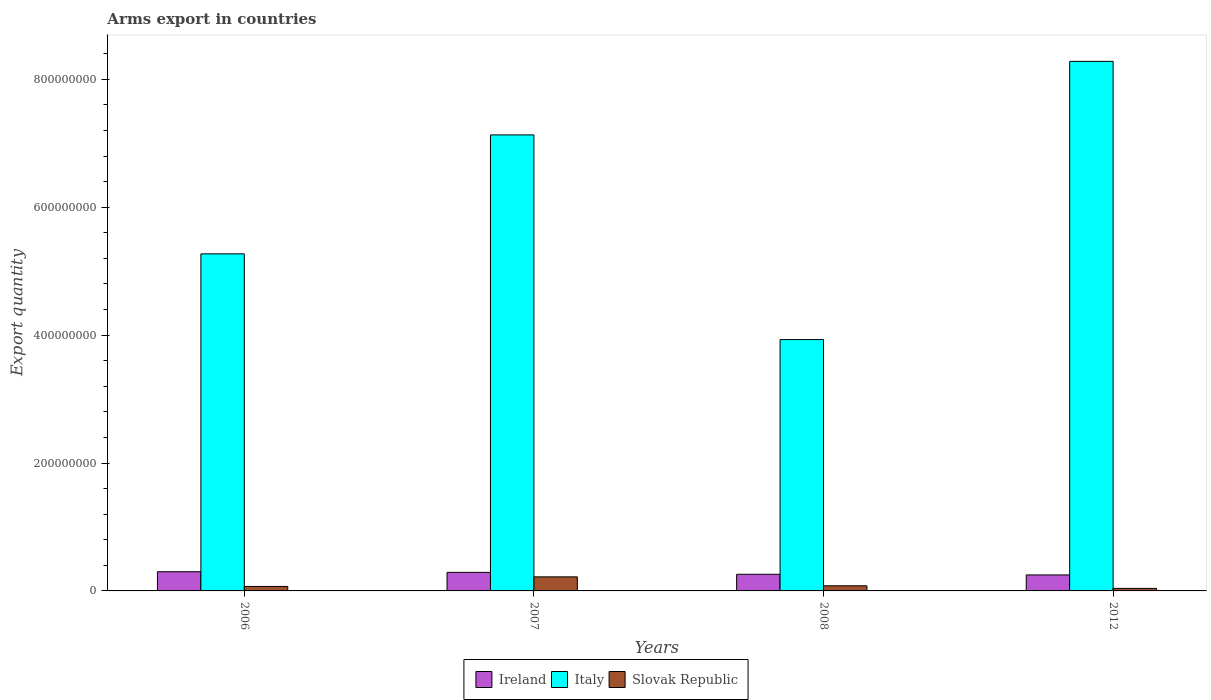How many groups of bars are there?
Ensure brevity in your answer.  4. What is the label of the 4th group of bars from the left?
Make the answer very short. 2012. In how many cases, is the number of bars for a given year not equal to the number of legend labels?
Your response must be concise. 0. What is the total arms export in Italy in 2006?
Give a very brief answer. 5.27e+08. Across all years, what is the maximum total arms export in Italy?
Provide a short and direct response. 8.28e+08. Across all years, what is the minimum total arms export in Slovak Republic?
Offer a very short reply. 4.00e+06. In which year was the total arms export in Ireland maximum?
Give a very brief answer. 2006. What is the total total arms export in Slovak Republic in the graph?
Keep it short and to the point. 4.10e+07. What is the difference between the total arms export in Slovak Republic in 2006 and that in 2007?
Give a very brief answer. -1.50e+07. What is the difference between the total arms export in Ireland in 2008 and the total arms export in Italy in 2006?
Ensure brevity in your answer.  -5.01e+08. What is the average total arms export in Ireland per year?
Ensure brevity in your answer.  2.75e+07. In the year 2007, what is the difference between the total arms export in Ireland and total arms export in Slovak Republic?
Provide a succinct answer. 7.00e+06. What is the ratio of the total arms export in Italy in 2006 to that in 2012?
Offer a very short reply. 0.64. Is the total arms export in Italy in 2006 less than that in 2012?
Your answer should be very brief. Yes. Is the difference between the total arms export in Ireland in 2008 and 2012 greater than the difference between the total arms export in Slovak Republic in 2008 and 2012?
Provide a short and direct response. No. What is the difference between the highest and the second highest total arms export in Slovak Republic?
Offer a terse response. 1.40e+07. What is the difference between the highest and the lowest total arms export in Italy?
Offer a terse response. 4.35e+08. What does the 1st bar from the left in 2006 represents?
Provide a short and direct response. Ireland. What does the 1st bar from the right in 2006 represents?
Provide a short and direct response. Slovak Republic. How many bars are there?
Provide a short and direct response. 12. Are all the bars in the graph horizontal?
Provide a short and direct response. No. How many years are there in the graph?
Make the answer very short. 4. What is the difference between two consecutive major ticks on the Y-axis?
Provide a short and direct response. 2.00e+08. Does the graph contain any zero values?
Give a very brief answer. No. Does the graph contain grids?
Your answer should be compact. No. How many legend labels are there?
Your response must be concise. 3. What is the title of the graph?
Give a very brief answer. Arms export in countries. What is the label or title of the Y-axis?
Your response must be concise. Export quantity. What is the Export quantity in Ireland in 2006?
Offer a terse response. 3.00e+07. What is the Export quantity in Italy in 2006?
Give a very brief answer. 5.27e+08. What is the Export quantity in Slovak Republic in 2006?
Your response must be concise. 7.00e+06. What is the Export quantity of Ireland in 2007?
Your response must be concise. 2.90e+07. What is the Export quantity of Italy in 2007?
Keep it short and to the point. 7.13e+08. What is the Export quantity in Slovak Republic in 2007?
Keep it short and to the point. 2.20e+07. What is the Export quantity of Ireland in 2008?
Your response must be concise. 2.60e+07. What is the Export quantity in Italy in 2008?
Make the answer very short. 3.93e+08. What is the Export quantity of Slovak Republic in 2008?
Give a very brief answer. 8.00e+06. What is the Export quantity in Ireland in 2012?
Offer a very short reply. 2.50e+07. What is the Export quantity of Italy in 2012?
Provide a short and direct response. 8.28e+08. Across all years, what is the maximum Export quantity in Ireland?
Offer a very short reply. 3.00e+07. Across all years, what is the maximum Export quantity of Italy?
Your response must be concise. 8.28e+08. Across all years, what is the maximum Export quantity of Slovak Republic?
Your answer should be very brief. 2.20e+07. Across all years, what is the minimum Export quantity of Ireland?
Give a very brief answer. 2.50e+07. Across all years, what is the minimum Export quantity of Italy?
Provide a succinct answer. 3.93e+08. Across all years, what is the minimum Export quantity in Slovak Republic?
Make the answer very short. 4.00e+06. What is the total Export quantity in Ireland in the graph?
Give a very brief answer. 1.10e+08. What is the total Export quantity in Italy in the graph?
Offer a very short reply. 2.46e+09. What is the total Export quantity in Slovak Republic in the graph?
Make the answer very short. 4.10e+07. What is the difference between the Export quantity of Italy in 2006 and that in 2007?
Your response must be concise. -1.86e+08. What is the difference between the Export quantity in Slovak Republic in 2006 and that in 2007?
Offer a terse response. -1.50e+07. What is the difference between the Export quantity of Italy in 2006 and that in 2008?
Offer a terse response. 1.34e+08. What is the difference between the Export quantity of Ireland in 2006 and that in 2012?
Keep it short and to the point. 5.00e+06. What is the difference between the Export quantity in Italy in 2006 and that in 2012?
Your response must be concise. -3.01e+08. What is the difference between the Export quantity in Ireland in 2007 and that in 2008?
Make the answer very short. 3.00e+06. What is the difference between the Export quantity in Italy in 2007 and that in 2008?
Your answer should be very brief. 3.20e+08. What is the difference between the Export quantity in Slovak Republic in 2007 and that in 2008?
Offer a terse response. 1.40e+07. What is the difference between the Export quantity in Italy in 2007 and that in 2012?
Your response must be concise. -1.15e+08. What is the difference between the Export quantity of Slovak Republic in 2007 and that in 2012?
Your answer should be very brief. 1.80e+07. What is the difference between the Export quantity of Italy in 2008 and that in 2012?
Make the answer very short. -4.35e+08. What is the difference between the Export quantity of Ireland in 2006 and the Export quantity of Italy in 2007?
Offer a very short reply. -6.83e+08. What is the difference between the Export quantity of Ireland in 2006 and the Export quantity of Slovak Republic in 2007?
Give a very brief answer. 8.00e+06. What is the difference between the Export quantity of Italy in 2006 and the Export quantity of Slovak Republic in 2007?
Your answer should be compact. 5.05e+08. What is the difference between the Export quantity in Ireland in 2006 and the Export quantity in Italy in 2008?
Your answer should be very brief. -3.63e+08. What is the difference between the Export quantity of Ireland in 2006 and the Export quantity of Slovak Republic in 2008?
Keep it short and to the point. 2.20e+07. What is the difference between the Export quantity of Italy in 2006 and the Export quantity of Slovak Republic in 2008?
Your answer should be very brief. 5.19e+08. What is the difference between the Export quantity in Ireland in 2006 and the Export quantity in Italy in 2012?
Make the answer very short. -7.98e+08. What is the difference between the Export quantity of Ireland in 2006 and the Export quantity of Slovak Republic in 2012?
Offer a very short reply. 2.60e+07. What is the difference between the Export quantity of Italy in 2006 and the Export quantity of Slovak Republic in 2012?
Offer a very short reply. 5.23e+08. What is the difference between the Export quantity in Ireland in 2007 and the Export quantity in Italy in 2008?
Ensure brevity in your answer.  -3.64e+08. What is the difference between the Export quantity in Ireland in 2007 and the Export quantity in Slovak Republic in 2008?
Provide a short and direct response. 2.10e+07. What is the difference between the Export quantity of Italy in 2007 and the Export quantity of Slovak Republic in 2008?
Keep it short and to the point. 7.05e+08. What is the difference between the Export quantity in Ireland in 2007 and the Export quantity in Italy in 2012?
Keep it short and to the point. -7.99e+08. What is the difference between the Export quantity in Ireland in 2007 and the Export quantity in Slovak Republic in 2012?
Provide a succinct answer. 2.50e+07. What is the difference between the Export quantity in Italy in 2007 and the Export quantity in Slovak Republic in 2012?
Your answer should be very brief. 7.09e+08. What is the difference between the Export quantity of Ireland in 2008 and the Export quantity of Italy in 2012?
Provide a short and direct response. -8.02e+08. What is the difference between the Export quantity in Ireland in 2008 and the Export quantity in Slovak Republic in 2012?
Provide a succinct answer. 2.20e+07. What is the difference between the Export quantity of Italy in 2008 and the Export quantity of Slovak Republic in 2012?
Provide a succinct answer. 3.89e+08. What is the average Export quantity in Ireland per year?
Offer a terse response. 2.75e+07. What is the average Export quantity of Italy per year?
Your answer should be very brief. 6.15e+08. What is the average Export quantity of Slovak Republic per year?
Provide a succinct answer. 1.02e+07. In the year 2006, what is the difference between the Export quantity in Ireland and Export quantity in Italy?
Your answer should be compact. -4.97e+08. In the year 2006, what is the difference between the Export quantity in Ireland and Export quantity in Slovak Republic?
Ensure brevity in your answer.  2.30e+07. In the year 2006, what is the difference between the Export quantity in Italy and Export quantity in Slovak Republic?
Your answer should be very brief. 5.20e+08. In the year 2007, what is the difference between the Export quantity of Ireland and Export quantity of Italy?
Your response must be concise. -6.84e+08. In the year 2007, what is the difference between the Export quantity in Italy and Export quantity in Slovak Republic?
Ensure brevity in your answer.  6.91e+08. In the year 2008, what is the difference between the Export quantity of Ireland and Export quantity of Italy?
Offer a very short reply. -3.67e+08. In the year 2008, what is the difference between the Export quantity in Ireland and Export quantity in Slovak Republic?
Make the answer very short. 1.80e+07. In the year 2008, what is the difference between the Export quantity of Italy and Export quantity of Slovak Republic?
Provide a succinct answer. 3.85e+08. In the year 2012, what is the difference between the Export quantity of Ireland and Export quantity of Italy?
Your response must be concise. -8.03e+08. In the year 2012, what is the difference between the Export quantity of Ireland and Export quantity of Slovak Republic?
Your answer should be compact. 2.10e+07. In the year 2012, what is the difference between the Export quantity in Italy and Export quantity in Slovak Republic?
Keep it short and to the point. 8.24e+08. What is the ratio of the Export quantity in Ireland in 2006 to that in 2007?
Make the answer very short. 1.03. What is the ratio of the Export quantity of Italy in 2006 to that in 2007?
Offer a terse response. 0.74. What is the ratio of the Export quantity in Slovak Republic in 2006 to that in 2007?
Your response must be concise. 0.32. What is the ratio of the Export quantity of Ireland in 2006 to that in 2008?
Provide a short and direct response. 1.15. What is the ratio of the Export quantity of Italy in 2006 to that in 2008?
Ensure brevity in your answer.  1.34. What is the ratio of the Export quantity of Slovak Republic in 2006 to that in 2008?
Provide a succinct answer. 0.88. What is the ratio of the Export quantity in Italy in 2006 to that in 2012?
Provide a succinct answer. 0.64. What is the ratio of the Export quantity of Ireland in 2007 to that in 2008?
Your answer should be compact. 1.12. What is the ratio of the Export quantity of Italy in 2007 to that in 2008?
Your answer should be compact. 1.81. What is the ratio of the Export quantity in Slovak Republic in 2007 to that in 2008?
Your answer should be very brief. 2.75. What is the ratio of the Export quantity in Ireland in 2007 to that in 2012?
Offer a terse response. 1.16. What is the ratio of the Export quantity of Italy in 2007 to that in 2012?
Ensure brevity in your answer.  0.86. What is the ratio of the Export quantity in Slovak Republic in 2007 to that in 2012?
Give a very brief answer. 5.5. What is the ratio of the Export quantity in Ireland in 2008 to that in 2012?
Offer a terse response. 1.04. What is the ratio of the Export quantity in Italy in 2008 to that in 2012?
Offer a terse response. 0.47. What is the ratio of the Export quantity in Slovak Republic in 2008 to that in 2012?
Provide a short and direct response. 2. What is the difference between the highest and the second highest Export quantity of Ireland?
Your answer should be very brief. 1.00e+06. What is the difference between the highest and the second highest Export quantity in Italy?
Your answer should be compact. 1.15e+08. What is the difference between the highest and the second highest Export quantity in Slovak Republic?
Give a very brief answer. 1.40e+07. What is the difference between the highest and the lowest Export quantity in Ireland?
Give a very brief answer. 5.00e+06. What is the difference between the highest and the lowest Export quantity in Italy?
Your answer should be very brief. 4.35e+08. What is the difference between the highest and the lowest Export quantity in Slovak Republic?
Your answer should be very brief. 1.80e+07. 